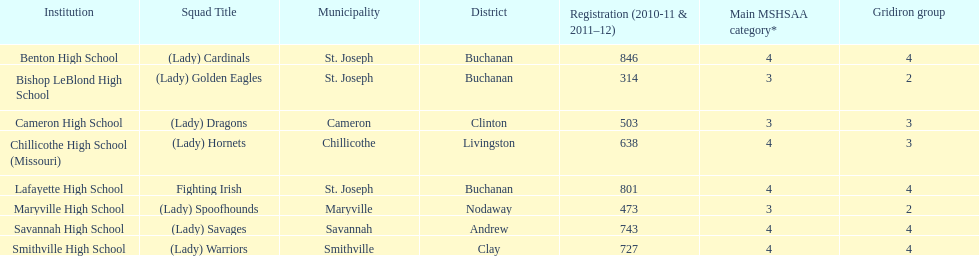How many schools are there in this conference? 8. 